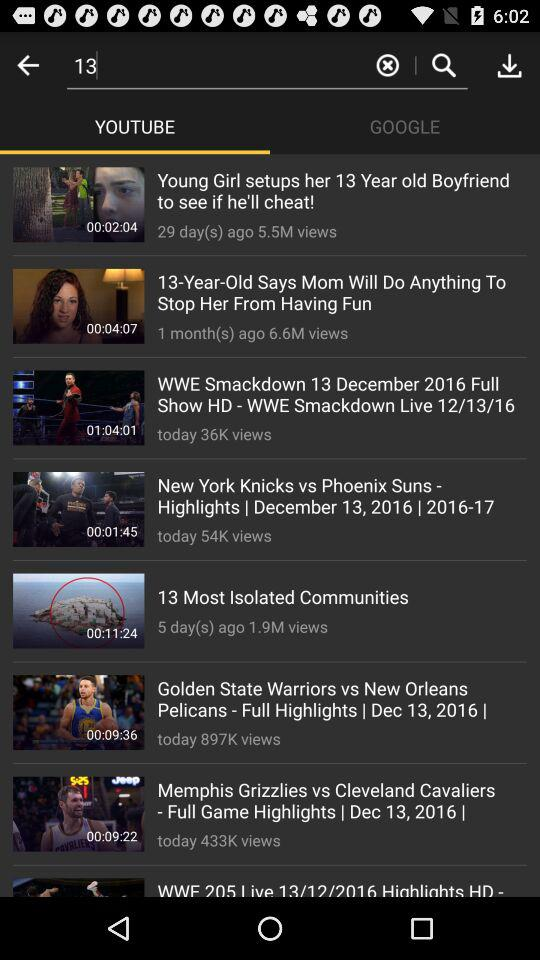How many days ago was the video "Young Girl setups her 13 Year old Boyfriend to see if he'll cheat" uploaded? The video was uploaded 29 days ago. 